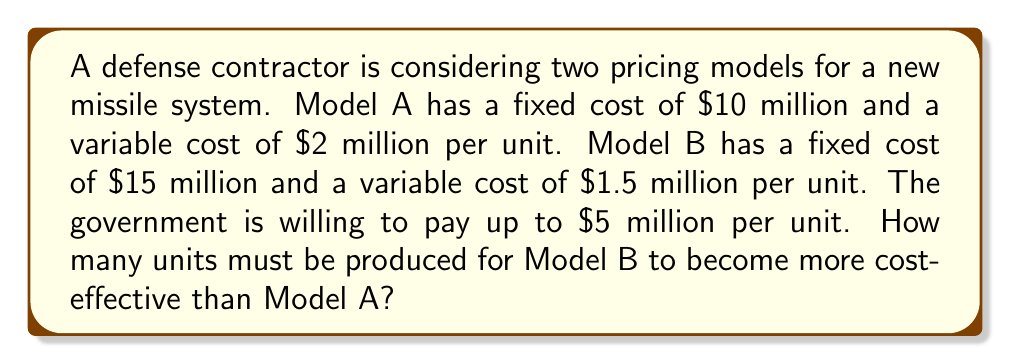Show me your answer to this math problem. Let's approach this step-by-step:

1) First, let's define our variables:
   $x$ = number of units produced
   $C_A$ = total cost for Model A
   $C_B$ = total cost for Model B

2) We can express the total cost for each model as a function of $x$:
   $C_A = 10 + 2x$ (in millions of dollars)
   $C_B = 15 + 1.5x$ (in millions of dollars)

3) Model B becomes more cost-effective when its total cost is less than Model A's:
   $C_B < C_A$
   $15 + 1.5x < 10 + 2x$

4) Let's solve this inequality:
   $15 + 1.5x < 10 + 2x$
   $5 + 1.5x < 2x$
   $5 < 0.5x$
   $10 < x$

5) Therefore, Model B becomes more cost-effective when more than 10 units are produced.

6) To find the exact number of units, we need to find the smallest integer greater than 10.

7) Cost-benefit analysis:
   At 11 units:
   $C_A = 10 + 2(11) = 32$ million
   $C_B = 15 + 1.5(11) = 31.5$ million

   The government is willing to pay up to $5 million per unit, so the revenue for 11 units would be $55 million.

   Profit for Model A: $55 - 32 = 23$ million
   Profit for Model B: $55 - 31.5 = 23.5$ million

   Model B is indeed more profitable at 11 units.
Answer: 11 units 